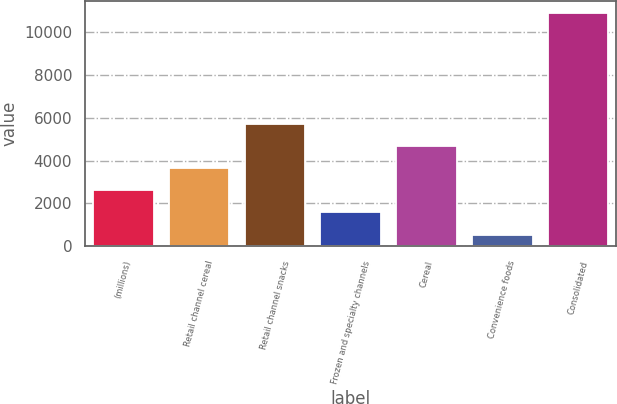Convert chart. <chart><loc_0><loc_0><loc_500><loc_500><bar_chart><fcel>(millions)<fcel>Retail channel cereal<fcel>Retail channel snacks<fcel>Frozen and specialty channels<fcel>Cereal<fcel>Convenience foods<fcel>Consolidated<nl><fcel>2619.42<fcel>3655.33<fcel>5727.15<fcel>1583.51<fcel>4691.24<fcel>547.6<fcel>10906.7<nl></chart> 